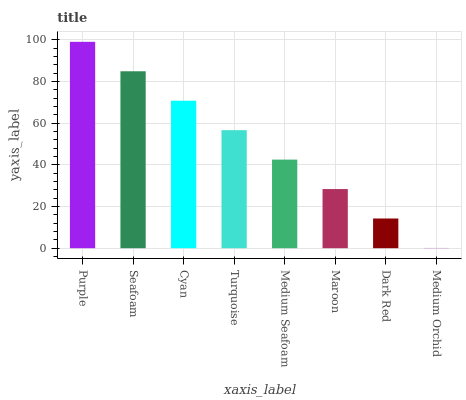Is Medium Orchid the minimum?
Answer yes or no. Yes. Is Purple the maximum?
Answer yes or no. Yes. Is Seafoam the minimum?
Answer yes or no. No. Is Seafoam the maximum?
Answer yes or no. No. Is Purple greater than Seafoam?
Answer yes or no. Yes. Is Seafoam less than Purple?
Answer yes or no. Yes. Is Seafoam greater than Purple?
Answer yes or no. No. Is Purple less than Seafoam?
Answer yes or no. No. Is Turquoise the high median?
Answer yes or no. Yes. Is Medium Seafoam the low median?
Answer yes or no. Yes. Is Maroon the high median?
Answer yes or no. No. Is Dark Red the low median?
Answer yes or no. No. 